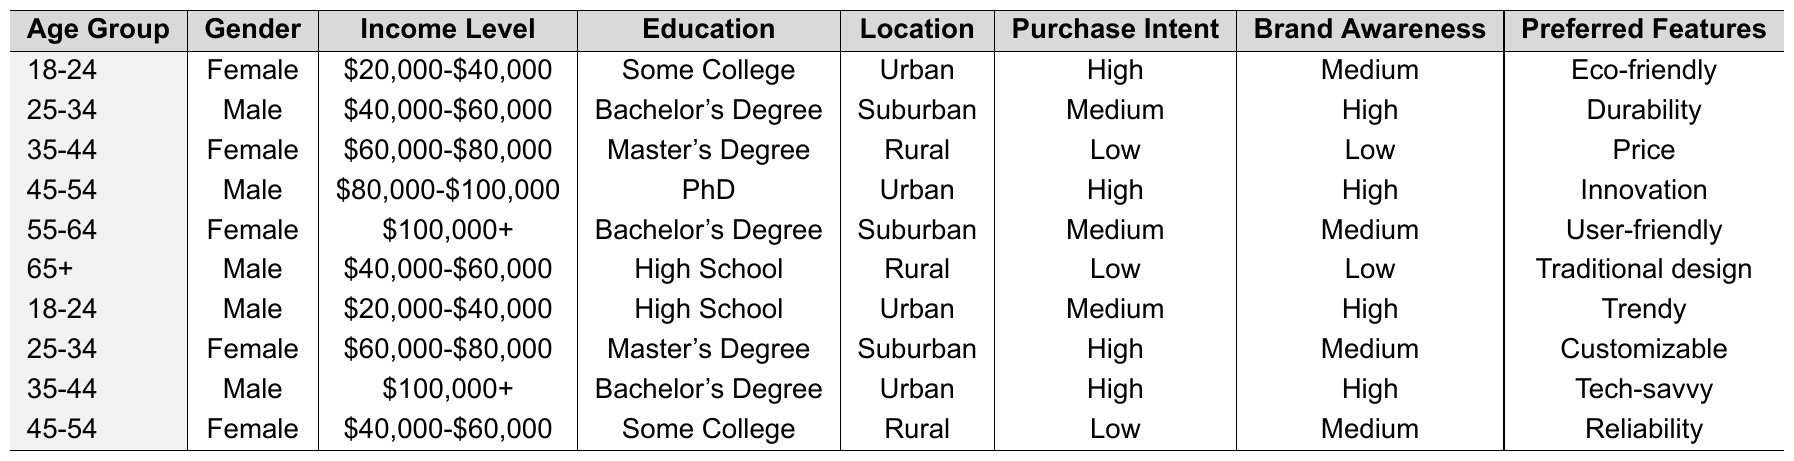What is the Purchase Intent of the 35-44 age group with a Master's Degree? Referring to the table, the 35-44 age group with a Master's Degree shows a Purchase Intent of Low.
Answer: Low Which gender has the highest Brand Awareness among the 45-54 age group? In the 45-54 age group, Males have a Brand Awareness of High while Females have Medium. Thus, it is Male.
Answer: Male How many individuals in the table have a Purchase Intent classified as High? By scanning the table, we notice there are four instances (18-24 Female, 45-54 Male, 25-34 Female, 35-44 Male) that indicate a Purchase Intent classified as High.
Answer: 4 Is there a female in the 65+ age group? The table does not list any females in the 65+ age group, as it only shows a Male with that age.
Answer: No What income level corresponds with the highest Purchase Intent of the 18-24 age group? The 18-24 age group has two entries: one Female with a Purchase Intent of High and one Male with Medium. The Female earns between $20,000-$40,000. Hence, the highest Purchase Intent corresponds to that income level.
Answer: $20,000-$40,000 Which location has the most individuals with a Purchase Intent classified as Low? Analyzing the data, we find the Rural location has three individuals (35-44 Female, 65+ Male, 45-54 Female) with a Purchase Intent classified as Low, indicating it's the most frequent location in this category.
Answer: Rural What is the median Income Level for the Male gender across the provided data? Looking at the income levels for males (from the data), we have $40,000-$60,000, $80,000-$100,000, and $100,000+. When these are ordered, the middle value or median is found to be $80,000-$100,000.
Answer: $80,000-$100,000 Which age group has the highest Purchase Intent and what feature do they prefer? In the age groups, the 18-24 and 25-34 both show the highest Purchase Intent of High. The 18-24 Female prefers Eco-friendly, and the 25-34 Female prefers Customizable.
Answer: Eco-friendly and Customizable How does the Brand Awareness of the 55-64 age group compare with that of the 25-34 age group? The 55-64 age group has Medium Brand Awareness versus High for the 25-34 age group. Therefore, the 25-34 age group has higher Brand Awareness compared to 55-64.
Answer: Higher for 25-34 age group What proportion of individuals prefer Eco-friendly features across all age groups? There is only one instance (18-24 Female) that prefers Eco-friendly features, out of ten total individuals in the table, resulting in a proportion of 1/10 or 10%.
Answer: 10% 